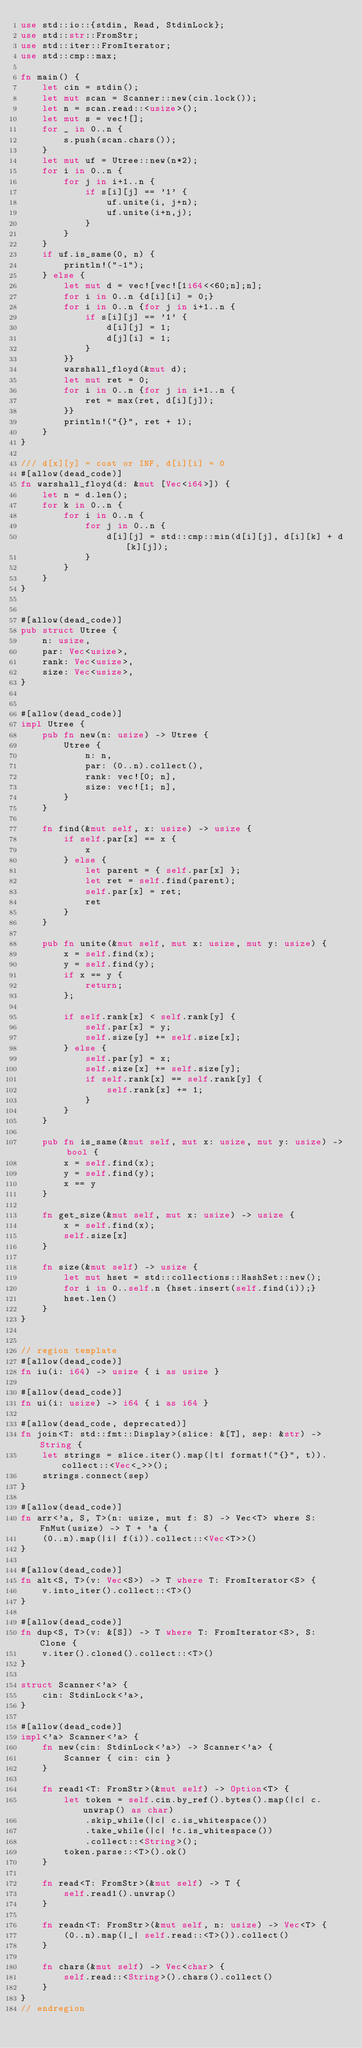Convert code to text. <code><loc_0><loc_0><loc_500><loc_500><_Rust_>use std::io::{stdin, Read, StdinLock};
use std::str::FromStr;
use std::iter::FromIterator;
use std::cmp::max;

fn main() {
    let cin = stdin();
    let mut scan = Scanner::new(cin.lock());
    let n = scan.read::<usize>();
    let mut s = vec![];
    for _ in 0..n {
        s.push(scan.chars());
    }
    let mut uf = Utree::new(n*2);
    for i in 0..n {
        for j in i+1..n {
            if s[i][j] == '1' {
                uf.unite(i, j+n);
                uf.unite(i+n,j);
            }
        }
    }
    if uf.is_same(0, n) {
        println!("-1");
    } else {
        let mut d = vec![vec![1i64<<60;n];n];
        for i in 0..n {d[i][i] = 0;}
        for i in 0..n {for j in i+1..n {
            if s[i][j] == '1' {
                d[i][j] = 1;
                d[j][i] = 1;
            }
        }}
        warshall_floyd(&mut d);
        let mut ret = 0;
        for i in 0..n {for j in i+1..n {
            ret = max(ret, d[i][j]);
        }}
        println!("{}", ret + 1);
    }
}

/// d[x][y] = cost or INF, d[i][i] = 0
#[allow(dead_code)]
fn warshall_floyd(d: &mut [Vec<i64>]) {
    let n = d.len();
    for k in 0..n {
        for i in 0..n {
            for j in 0..n {
                d[i][j] = std::cmp::min(d[i][j], d[i][k] + d[k][j]);
            }
        }
    }
}


#[allow(dead_code)]
pub struct Utree {
    n: usize,
    par: Vec<usize>,
    rank: Vec<usize>,
    size: Vec<usize>,
}


#[allow(dead_code)]
impl Utree {
    pub fn new(n: usize) -> Utree {
        Utree {
            n: n,
            par: (0..n).collect(),
            rank: vec![0; n],
            size: vec![1; n],
        }
    }

    fn find(&mut self, x: usize) -> usize {
        if self.par[x] == x {
            x
        } else {
            let parent = { self.par[x] };
            let ret = self.find(parent);
            self.par[x] = ret;
            ret
        }
    }

    pub fn unite(&mut self, mut x: usize, mut y: usize) {
        x = self.find(x);
        y = self.find(y);
        if x == y {
            return;
        };

        if self.rank[x] < self.rank[y] {
            self.par[x] = y;
            self.size[y] += self.size[x];
        } else {
            self.par[y] = x;
            self.size[x] += self.size[y];
            if self.rank[x] == self.rank[y] {
                self.rank[x] += 1;
            }
        }
    }

    pub fn is_same(&mut self, mut x: usize, mut y: usize) -> bool {
        x = self.find(x);
        y = self.find(y);
        x == y
    }

    fn get_size(&mut self, mut x: usize) -> usize {
        x = self.find(x);
        self.size[x]
    }

    fn size(&mut self) -> usize {
        let mut hset = std::collections::HashSet::new();
        for i in 0..self.n {hset.insert(self.find(i));}
        hset.len()
    }
}


// region template
#[allow(dead_code)]
fn iu(i: i64) -> usize { i as usize }

#[allow(dead_code)]
fn ui(i: usize) -> i64 { i as i64 }

#[allow(dead_code, deprecated)]
fn join<T: std::fmt::Display>(slice: &[T], sep: &str) -> String {
    let strings = slice.iter().map(|t| format!("{}", t)).collect::<Vec<_>>();
    strings.connect(sep)
}

#[allow(dead_code)]
fn arr<'a, S, T>(n: usize, mut f: S) -> Vec<T> where S: FnMut(usize) -> T + 'a {
    (0..n).map(|i| f(i)).collect::<Vec<T>>()
}

#[allow(dead_code)]
fn alt<S, T>(v: Vec<S>) -> T where T: FromIterator<S> {
    v.into_iter().collect::<T>()
}

#[allow(dead_code)]
fn dup<S, T>(v: &[S]) -> T where T: FromIterator<S>, S: Clone {
    v.iter().cloned().collect::<T>()
}

struct Scanner<'a> {
    cin: StdinLock<'a>,
}

#[allow(dead_code)]
impl<'a> Scanner<'a> {
    fn new(cin: StdinLock<'a>) -> Scanner<'a> {
        Scanner { cin: cin }
    }

    fn read1<T: FromStr>(&mut self) -> Option<T> {
        let token = self.cin.by_ref().bytes().map(|c| c.unwrap() as char)
            .skip_while(|c| c.is_whitespace())
            .take_while(|c| !c.is_whitespace())
            .collect::<String>();
        token.parse::<T>().ok()
    }

    fn read<T: FromStr>(&mut self) -> T {
        self.read1().unwrap()
    }

    fn readn<T: FromStr>(&mut self, n: usize) -> Vec<T> {
        (0..n).map(|_| self.read::<T>()).collect()
    }

    fn chars(&mut self) -> Vec<char> {
        self.read::<String>().chars().collect()
    }
}
// endregion</code> 